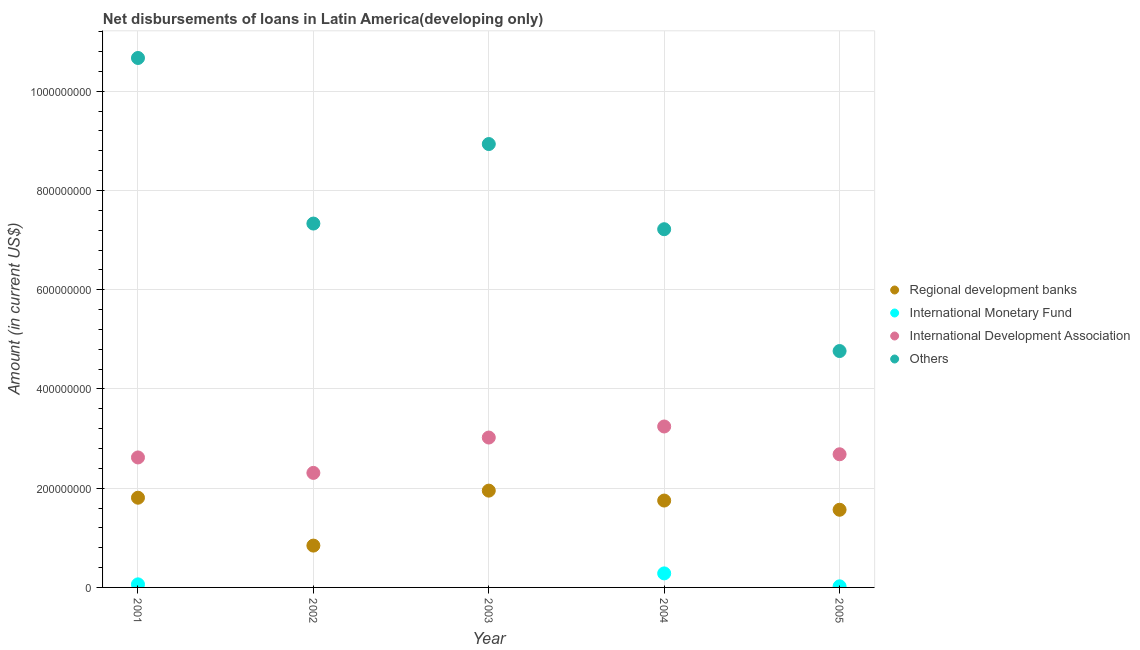How many different coloured dotlines are there?
Offer a very short reply. 4. Across all years, what is the maximum amount of loan disimbursed by international monetary fund?
Make the answer very short. 2.83e+07. Across all years, what is the minimum amount of loan disimbursed by other organisations?
Your response must be concise. 4.76e+08. In which year was the amount of loan disimbursed by international monetary fund maximum?
Your answer should be compact. 2004. What is the total amount of loan disimbursed by other organisations in the graph?
Offer a very short reply. 3.89e+09. What is the difference between the amount of loan disimbursed by regional development banks in 2003 and that in 2005?
Provide a succinct answer. 3.85e+07. What is the difference between the amount of loan disimbursed by international monetary fund in 2004 and the amount of loan disimbursed by regional development banks in 2005?
Your response must be concise. -1.28e+08. What is the average amount of loan disimbursed by international development association per year?
Your answer should be compact. 2.78e+08. In the year 2003, what is the difference between the amount of loan disimbursed by regional development banks and amount of loan disimbursed by other organisations?
Offer a terse response. -6.99e+08. In how many years, is the amount of loan disimbursed by international development association greater than 40000000 US$?
Give a very brief answer. 5. What is the ratio of the amount of loan disimbursed by other organisations in 2002 to that in 2005?
Your answer should be compact. 1.54. What is the difference between the highest and the second highest amount of loan disimbursed by international monetary fund?
Ensure brevity in your answer.  2.21e+07. What is the difference between the highest and the lowest amount of loan disimbursed by international development association?
Offer a terse response. 9.35e+07. In how many years, is the amount of loan disimbursed by international development association greater than the average amount of loan disimbursed by international development association taken over all years?
Your response must be concise. 2. Is it the case that in every year, the sum of the amount of loan disimbursed by international development association and amount of loan disimbursed by regional development banks is greater than the sum of amount of loan disimbursed by other organisations and amount of loan disimbursed by international monetary fund?
Provide a short and direct response. No. Does the amount of loan disimbursed by regional development banks monotonically increase over the years?
Give a very brief answer. No. Is the amount of loan disimbursed by international monetary fund strictly less than the amount of loan disimbursed by international development association over the years?
Your answer should be very brief. Yes. How many years are there in the graph?
Ensure brevity in your answer.  5. Are the values on the major ticks of Y-axis written in scientific E-notation?
Provide a short and direct response. No. Does the graph contain grids?
Keep it short and to the point. Yes. How many legend labels are there?
Your response must be concise. 4. How are the legend labels stacked?
Ensure brevity in your answer.  Vertical. What is the title of the graph?
Keep it short and to the point. Net disbursements of loans in Latin America(developing only). What is the label or title of the X-axis?
Provide a short and direct response. Year. What is the Amount (in current US$) in Regional development banks in 2001?
Provide a succinct answer. 1.81e+08. What is the Amount (in current US$) of International Monetary Fund in 2001?
Make the answer very short. 6.19e+06. What is the Amount (in current US$) in International Development Association in 2001?
Your answer should be compact. 2.62e+08. What is the Amount (in current US$) in Others in 2001?
Ensure brevity in your answer.  1.07e+09. What is the Amount (in current US$) in Regional development banks in 2002?
Provide a succinct answer. 8.43e+07. What is the Amount (in current US$) of International Development Association in 2002?
Give a very brief answer. 2.31e+08. What is the Amount (in current US$) of Others in 2002?
Offer a terse response. 7.33e+08. What is the Amount (in current US$) of Regional development banks in 2003?
Offer a terse response. 1.95e+08. What is the Amount (in current US$) of International Monetary Fund in 2003?
Your response must be concise. 0. What is the Amount (in current US$) in International Development Association in 2003?
Offer a terse response. 3.02e+08. What is the Amount (in current US$) in Others in 2003?
Your response must be concise. 8.94e+08. What is the Amount (in current US$) in Regional development banks in 2004?
Make the answer very short. 1.75e+08. What is the Amount (in current US$) of International Monetary Fund in 2004?
Provide a succinct answer. 2.83e+07. What is the Amount (in current US$) of International Development Association in 2004?
Ensure brevity in your answer.  3.24e+08. What is the Amount (in current US$) of Others in 2004?
Provide a succinct answer. 7.22e+08. What is the Amount (in current US$) in Regional development banks in 2005?
Your answer should be compact. 1.57e+08. What is the Amount (in current US$) of International Monetary Fund in 2005?
Give a very brief answer. 2.20e+06. What is the Amount (in current US$) in International Development Association in 2005?
Keep it short and to the point. 2.68e+08. What is the Amount (in current US$) of Others in 2005?
Provide a short and direct response. 4.76e+08. Across all years, what is the maximum Amount (in current US$) in Regional development banks?
Your answer should be very brief. 1.95e+08. Across all years, what is the maximum Amount (in current US$) of International Monetary Fund?
Your answer should be very brief. 2.83e+07. Across all years, what is the maximum Amount (in current US$) in International Development Association?
Offer a terse response. 3.24e+08. Across all years, what is the maximum Amount (in current US$) of Others?
Offer a very short reply. 1.07e+09. Across all years, what is the minimum Amount (in current US$) of Regional development banks?
Offer a terse response. 8.43e+07. Across all years, what is the minimum Amount (in current US$) of International Monetary Fund?
Your response must be concise. 0. Across all years, what is the minimum Amount (in current US$) in International Development Association?
Keep it short and to the point. 2.31e+08. Across all years, what is the minimum Amount (in current US$) of Others?
Provide a succinct answer. 4.76e+08. What is the total Amount (in current US$) in Regional development banks in the graph?
Offer a very short reply. 7.92e+08. What is the total Amount (in current US$) of International Monetary Fund in the graph?
Provide a short and direct response. 3.67e+07. What is the total Amount (in current US$) of International Development Association in the graph?
Provide a succinct answer. 1.39e+09. What is the total Amount (in current US$) of Others in the graph?
Provide a succinct answer. 3.89e+09. What is the difference between the Amount (in current US$) of Regional development banks in 2001 and that in 2002?
Ensure brevity in your answer.  9.65e+07. What is the difference between the Amount (in current US$) in International Development Association in 2001 and that in 2002?
Offer a very short reply. 3.11e+07. What is the difference between the Amount (in current US$) of Others in 2001 and that in 2002?
Provide a succinct answer. 3.34e+08. What is the difference between the Amount (in current US$) in Regional development banks in 2001 and that in 2003?
Your answer should be compact. -1.43e+07. What is the difference between the Amount (in current US$) of International Development Association in 2001 and that in 2003?
Give a very brief answer. -4.01e+07. What is the difference between the Amount (in current US$) of Others in 2001 and that in 2003?
Offer a very short reply. 1.73e+08. What is the difference between the Amount (in current US$) in Regional development banks in 2001 and that in 2004?
Offer a terse response. 5.72e+06. What is the difference between the Amount (in current US$) in International Monetary Fund in 2001 and that in 2004?
Provide a short and direct response. -2.21e+07. What is the difference between the Amount (in current US$) in International Development Association in 2001 and that in 2004?
Make the answer very short. -6.24e+07. What is the difference between the Amount (in current US$) in Others in 2001 and that in 2004?
Make the answer very short. 3.45e+08. What is the difference between the Amount (in current US$) in Regional development banks in 2001 and that in 2005?
Your response must be concise. 2.43e+07. What is the difference between the Amount (in current US$) of International Monetary Fund in 2001 and that in 2005?
Offer a terse response. 3.99e+06. What is the difference between the Amount (in current US$) of International Development Association in 2001 and that in 2005?
Offer a very short reply. -6.39e+06. What is the difference between the Amount (in current US$) of Others in 2001 and that in 2005?
Keep it short and to the point. 5.91e+08. What is the difference between the Amount (in current US$) in Regional development banks in 2002 and that in 2003?
Provide a succinct answer. -1.11e+08. What is the difference between the Amount (in current US$) in International Development Association in 2002 and that in 2003?
Provide a succinct answer. -7.13e+07. What is the difference between the Amount (in current US$) in Others in 2002 and that in 2003?
Your answer should be very brief. -1.60e+08. What is the difference between the Amount (in current US$) in Regional development banks in 2002 and that in 2004?
Keep it short and to the point. -9.08e+07. What is the difference between the Amount (in current US$) of International Development Association in 2002 and that in 2004?
Give a very brief answer. -9.35e+07. What is the difference between the Amount (in current US$) in Others in 2002 and that in 2004?
Provide a succinct answer. 1.14e+07. What is the difference between the Amount (in current US$) in Regional development banks in 2002 and that in 2005?
Make the answer very short. -7.22e+07. What is the difference between the Amount (in current US$) in International Development Association in 2002 and that in 2005?
Give a very brief answer. -3.75e+07. What is the difference between the Amount (in current US$) of Others in 2002 and that in 2005?
Provide a succinct answer. 2.57e+08. What is the difference between the Amount (in current US$) in Regional development banks in 2003 and that in 2004?
Offer a very short reply. 2.00e+07. What is the difference between the Amount (in current US$) of International Development Association in 2003 and that in 2004?
Ensure brevity in your answer.  -2.23e+07. What is the difference between the Amount (in current US$) of Others in 2003 and that in 2004?
Offer a very short reply. 1.72e+08. What is the difference between the Amount (in current US$) of Regional development banks in 2003 and that in 2005?
Your answer should be compact. 3.85e+07. What is the difference between the Amount (in current US$) in International Development Association in 2003 and that in 2005?
Your answer should be compact. 3.37e+07. What is the difference between the Amount (in current US$) of Others in 2003 and that in 2005?
Give a very brief answer. 4.17e+08. What is the difference between the Amount (in current US$) in Regional development banks in 2004 and that in 2005?
Ensure brevity in your answer.  1.86e+07. What is the difference between the Amount (in current US$) of International Monetary Fund in 2004 and that in 2005?
Make the answer very short. 2.61e+07. What is the difference between the Amount (in current US$) in International Development Association in 2004 and that in 2005?
Offer a terse response. 5.60e+07. What is the difference between the Amount (in current US$) in Others in 2004 and that in 2005?
Keep it short and to the point. 2.46e+08. What is the difference between the Amount (in current US$) in Regional development banks in 2001 and the Amount (in current US$) in International Development Association in 2002?
Your answer should be compact. -5.00e+07. What is the difference between the Amount (in current US$) of Regional development banks in 2001 and the Amount (in current US$) of Others in 2002?
Offer a very short reply. -5.53e+08. What is the difference between the Amount (in current US$) in International Monetary Fund in 2001 and the Amount (in current US$) in International Development Association in 2002?
Give a very brief answer. -2.25e+08. What is the difference between the Amount (in current US$) in International Monetary Fund in 2001 and the Amount (in current US$) in Others in 2002?
Ensure brevity in your answer.  -7.27e+08. What is the difference between the Amount (in current US$) in International Development Association in 2001 and the Amount (in current US$) in Others in 2002?
Your answer should be compact. -4.71e+08. What is the difference between the Amount (in current US$) in Regional development banks in 2001 and the Amount (in current US$) in International Development Association in 2003?
Your answer should be very brief. -1.21e+08. What is the difference between the Amount (in current US$) of Regional development banks in 2001 and the Amount (in current US$) of Others in 2003?
Provide a succinct answer. -7.13e+08. What is the difference between the Amount (in current US$) in International Monetary Fund in 2001 and the Amount (in current US$) in International Development Association in 2003?
Keep it short and to the point. -2.96e+08. What is the difference between the Amount (in current US$) of International Monetary Fund in 2001 and the Amount (in current US$) of Others in 2003?
Your answer should be very brief. -8.87e+08. What is the difference between the Amount (in current US$) of International Development Association in 2001 and the Amount (in current US$) of Others in 2003?
Your answer should be compact. -6.32e+08. What is the difference between the Amount (in current US$) of Regional development banks in 2001 and the Amount (in current US$) of International Monetary Fund in 2004?
Offer a terse response. 1.53e+08. What is the difference between the Amount (in current US$) in Regional development banks in 2001 and the Amount (in current US$) in International Development Association in 2004?
Keep it short and to the point. -1.44e+08. What is the difference between the Amount (in current US$) of Regional development banks in 2001 and the Amount (in current US$) of Others in 2004?
Give a very brief answer. -5.41e+08. What is the difference between the Amount (in current US$) in International Monetary Fund in 2001 and the Amount (in current US$) in International Development Association in 2004?
Provide a succinct answer. -3.18e+08. What is the difference between the Amount (in current US$) of International Monetary Fund in 2001 and the Amount (in current US$) of Others in 2004?
Your response must be concise. -7.16e+08. What is the difference between the Amount (in current US$) in International Development Association in 2001 and the Amount (in current US$) in Others in 2004?
Offer a very short reply. -4.60e+08. What is the difference between the Amount (in current US$) of Regional development banks in 2001 and the Amount (in current US$) of International Monetary Fund in 2005?
Give a very brief answer. 1.79e+08. What is the difference between the Amount (in current US$) in Regional development banks in 2001 and the Amount (in current US$) in International Development Association in 2005?
Offer a terse response. -8.76e+07. What is the difference between the Amount (in current US$) in Regional development banks in 2001 and the Amount (in current US$) in Others in 2005?
Keep it short and to the point. -2.96e+08. What is the difference between the Amount (in current US$) of International Monetary Fund in 2001 and the Amount (in current US$) of International Development Association in 2005?
Provide a succinct answer. -2.62e+08. What is the difference between the Amount (in current US$) in International Monetary Fund in 2001 and the Amount (in current US$) in Others in 2005?
Your response must be concise. -4.70e+08. What is the difference between the Amount (in current US$) in International Development Association in 2001 and the Amount (in current US$) in Others in 2005?
Your answer should be very brief. -2.14e+08. What is the difference between the Amount (in current US$) in Regional development banks in 2002 and the Amount (in current US$) in International Development Association in 2003?
Provide a succinct answer. -2.18e+08. What is the difference between the Amount (in current US$) of Regional development banks in 2002 and the Amount (in current US$) of Others in 2003?
Your response must be concise. -8.09e+08. What is the difference between the Amount (in current US$) of International Development Association in 2002 and the Amount (in current US$) of Others in 2003?
Keep it short and to the point. -6.63e+08. What is the difference between the Amount (in current US$) in Regional development banks in 2002 and the Amount (in current US$) in International Monetary Fund in 2004?
Offer a terse response. 5.60e+07. What is the difference between the Amount (in current US$) of Regional development banks in 2002 and the Amount (in current US$) of International Development Association in 2004?
Give a very brief answer. -2.40e+08. What is the difference between the Amount (in current US$) of Regional development banks in 2002 and the Amount (in current US$) of Others in 2004?
Provide a succinct answer. -6.38e+08. What is the difference between the Amount (in current US$) of International Development Association in 2002 and the Amount (in current US$) of Others in 2004?
Your answer should be very brief. -4.91e+08. What is the difference between the Amount (in current US$) in Regional development banks in 2002 and the Amount (in current US$) in International Monetary Fund in 2005?
Your answer should be compact. 8.21e+07. What is the difference between the Amount (in current US$) in Regional development banks in 2002 and the Amount (in current US$) in International Development Association in 2005?
Provide a succinct answer. -1.84e+08. What is the difference between the Amount (in current US$) in Regional development banks in 2002 and the Amount (in current US$) in Others in 2005?
Offer a very short reply. -3.92e+08. What is the difference between the Amount (in current US$) of International Development Association in 2002 and the Amount (in current US$) of Others in 2005?
Provide a succinct answer. -2.46e+08. What is the difference between the Amount (in current US$) in Regional development banks in 2003 and the Amount (in current US$) in International Monetary Fund in 2004?
Keep it short and to the point. 1.67e+08. What is the difference between the Amount (in current US$) in Regional development banks in 2003 and the Amount (in current US$) in International Development Association in 2004?
Keep it short and to the point. -1.29e+08. What is the difference between the Amount (in current US$) in Regional development banks in 2003 and the Amount (in current US$) in Others in 2004?
Give a very brief answer. -5.27e+08. What is the difference between the Amount (in current US$) of International Development Association in 2003 and the Amount (in current US$) of Others in 2004?
Your answer should be very brief. -4.20e+08. What is the difference between the Amount (in current US$) of Regional development banks in 2003 and the Amount (in current US$) of International Monetary Fund in 2005?
Your answer should be very brief. 1.93e+08. What is the difference between the Amount (in current US$) in Regional development banks in 2003 and the Amount (in current US$) in International Development Association in 2005?
Offer a terse response. -7.33e+07. What is the difference between the Amount (in current US$) in Regional development banks in 2003 and the Amount (in current US$) in Others in 2005?
Provide a short and direct response. -2.81e+08. What is the difference between the Amount (in current US$) of International Development Association in 2003 and the Amount (in current US$) of Others in 2005?
Provide a succinct answer. -1.74e+08. What is the difference between the Amount (in current US$) of Regional development banks in 2004 and the Amount (in current US$) of International Monetary Fund in 2005?
Keep it short and to the point. 1.73e+08. What is the difference between the Amount (in current US$) in Regional development banks in 2004 and the Amount (in current US$) in International Development Association in 2005?
Ensure brevity in your answer.  -9.33e+07. What is the difference between the Amount (in current US$) of Regional development banks in 2004 and the Amount (in current US$) of Others in 2005?
Your answer should be compact. -3.01e+08. What is the difference between the Amount (in current US$) of International Monetary Fund in 2004 and the Amount (in current US$) of International Development Association in 2005?
Give a very brief answer. -2.40e+08. What is the difference between the Amount (in current US$) of International Monetary Fund in 2004 and the Amount (in current US$) of Others in 2005?
Keep it short and to the point. -4.48e+08. What is the difference between the Amount (in current US$) of International Development Association in 2004 and the Amount (in current US$) of Others in 2005?
Provide a succinct answer. -1.52e+08. What is the average Amount (in current US$) of Regional development banks per year?
Ensure brevity in your answer.  1.58e+08. What is the average Amount (in current US$) of International Monetary Fund per year?
Provide a succinct answer. 7.33e+06. What is the average Amount (in current US$) of International Development Association per year?
Ensure brevity in your answer.  2.78e+08. What is the average Amount (in current US$) in Others per year?
Provide a succinct answer. 7.78e+08. In the year 2001, what is the difference between the Amount (in current US$) of Regional development banks and Amount (in current US$) of International Monetary Fund?
Offer a terse response. 1.75e+08. In the year 2001, what is the difference between the Amount (in current US$) in Regional development banks and Amount (in current US$) in International Development Association?
Give a very brief answer. -8.12e+07. In the year 2001, what is the difference between the Amount (in current US$) in Regional development banks and Amount (in current US$) in Others?
Make the answer very short. -8.86e+08. In the year 2001, what is the difference between the Amount (in current US$) of International Monetary Fund and Amount (in current US$) of International Development Association?
Make the answer very short. -2.56e+08. In the year 2001, what is the difference between the Amount (in current US$) of International Monetary Fund and Amount (in current US$) of Others?
Give a very brief answer. -1.06e+09. In the year 2001, what is the difference between the Amount (in current US$) of International Development Association and Amount (in current US$) of Others?
Give a very brief answer. -8.05e+08. In the year 2002, what is the difference between the Amount (in current US$) of Regional development banks and Amount (in current US$) of International Development Association?
Offer a terse response. -1.47e+08. In the year 2002, what is the difference between the Amount (in current US$) of Regional development banks and Amount (in current US$) of Others?
Offer a terse response. -6.49e+08. In the year 2002, what is the difference between the Amount (in current US$) of International Development Association and Amount (in current US$) of Others?
Keep it short and to the point. -5.03e+08. In the year 2003, what is the difference between the Amount (in current US$) of Regional development banks and Amount (in current US$) of International Development Association?
Your answer should be very brief. -1.07e+08. In the year 2003, what is the difference between the Amount (in current US$) in Regional development banks and Amount (in current US$) in Others?
Provide a short and direct response. -6.99e+08. In the year 2003, what is the difference between the Amount (in current US$) of International Development Association and Amount (in current US$) of Others?
Keep it short and to the point. -5.92e+08. In the year 2004, what is the difference between the Amount (in current US$) of Regional development banks and Amount (in current US$) of International Monetary Fund?
Give a very brief answer. 1.47e+08. In the year 2004, what is the difference between the Amount (in current US$) in Regional development banks and Amount (in current US$) in International Development Association?
Give a very brief answer. -1.49e+08. In the year 2004, what is the difference between the Amount (in current US$) of Regional development banks and Amount (in current US$) of Others?
Your answer should be compact. -5.47e+08. In the year 2004, what is the difference between the Amount (in current US$) in International Monetary Fund and Amount (in current US$) in International Development Association?
Offer a terse response. -2.96e+08. In the year 2004, what is the difference between the Amount (in current US$) of International Monetary Fund and Amount (in current US$) of Others?
Offer a very short reply. -6.94e+08. In the year 2004, what is the difference between the Amount (in current US$) in International Development Association and Amount (in current US$) in Others?
Your answer should be very brief. -3.98e+08. In the year 2005, what is the difference between the Amount (in current US$) of Regional development banks and Amount (in current US$) of International Monetary Fund?
Provide a succinct answer. 1.54e+08. In the year 2005, what is the difference between the Amount (in current US$) in Regional development banks and Amount (in current US$) in International Development Association?
Your response must be concise. -1.12e+08. In the year 2005, what is the difference between the Amount (in current US$) of Regional development banks and Amount (in current US$) of Others?
Offer a terse response. -3.20e+08. In the year 2005, what is the difference between the Amount (in current US$) of International Monetary Fund and Amount (in current US$) of International Development Association?
Give a very brief answer. -2.66e+08. In the year 2005, what is the difference between the Amount (in current US$) in International Monetary Fund and Amount (in current US$) in Others?
Offer a very short reply. -4.74e+08. In the year 2005, what is the difference between the Amount (in current US$) in International Development Association and Amount (in current US$) in Others?
Your answer should be compact. -2.08e+08. What is the ratio of the Amount (in current US$) in Regional development banks in 2001 to that in 2002?
Offer a terse response. 2.14. What is the ratio of the Amount (in current US$) in International Development Association in 2001 to that in 2002?
Give a very brief answer. 1.13. What is the ratio of the Amount (in current US$) of Others in 2001 to that in 2002?
Offer a terse response. 1.46. What is the ratio of the Amount (in current US$) in Regional development banks in 2001 to that in 2003?
Provide a short and direct response. 0.93. What is the ratio of the Amount (in current US$) in International Development Association in 2001 to that in 2003?
Keep it short and to the point. 0.87. What is the ratio of the Amount (in current US$) of Others in 2001 to that in 2003?
Keep it short and to the point. 1.19. What is the ratio of the Amount (in current US$) in Regional development banks in 2001 to that in 2004?
Your answer should be very brief. 1.03. What is the ratio of the Amount (in current US$) of International Monetary Fund in 2001 to that in 2004?
Your answer should be very brief. 0.22. What is the ratio of the Amount (in current US$) of International Development Association in 2001 to that in 2004?
Keep it short and to the point. 0.81. What is the ratio of the Amount (in current US$) in Others in 2001 to that in 2004?
Make the answer very short. 1.48. What is the ratio of the Amount (in current US$) of Regional development banks in 2001 to that in 2005?
Ensure brevity in your answer.  1.16. What is the ratio of the Amount (in current US$) of International Monetary Fund in 2001 to that in 2005?
Your response must be concise. 2.81. What is the ratio of the Amount (in current US$) in International Development Association in 2001 to that in 2005?
Ensure brevity in your answer.  0.98. What is the ratio of the Amount (in current US$) in Others in 2001 to that in 2005?
Your answer should be very brief. 2.24. What is the ratio of the Amount (in current US$) of Regional development banks in 2002 to that in 2003?
Make the answer very short. 0.43. What is the ratio of the Amount (in current US$) of International Development Association in 2002 to that in 2003?
Offer a very short reply. 0.76. What is the ratio of the Amount (in current US$) of Others in 2002 to that in 2003?
Keep it short and to the point. 0.82. What is the ratio of the Amount (in current US$) of Regional development banks in 2002 to that in 2004?
Give a very brief answer. 0.48. What is the ratio of the Amount (in current US$) in International Development Association in 2002 to that in 2004?
Keep it short and to the point. 0.71. What is the ratio of the Amount (in current US$) of Others in 2002 to that in 2004?
Ensure brevity in your answer.  1.02. What is the ratio of the Amount (in current US$) of Regional development banks in 2002 to that in 2005?
Provide a succinct answer. 0.54. What is the ratio of the Amount (in current US$) of International Development Association in 2002 to that in 2005?
Ensure brevity in your answer.  0.86. What is the ratio of the Amount (in current US$) in Others in 2002 to that in 2005?
Ensure brevity in your answer.  1.54. What is the ratio of the Amount (in current US$) of Regional development banks in 2003 to that in 2004?
Give a very brief answer. 1.11. What is the ratio of the Amount (in current US$) of International Development Association in 2003 to that in 2004?
Your answer should be compact. 0.93. What is the ratio of the Amount (in current US$) in Others in 2003 to that in 2004?
Give a very brief answer. 1.24. What is the ratio of the Amount (in current US$) in Regional development banks in 2003 to that in 2005?
Offer a very short reply. 1.25. What is the ratio of the Amount (in current US$) in International Development Association in 2003 to that in 2005?
Your answer should be very brief. 1.13. What is the ratio of the Amount (in current US$) in Others in 2003 to that in 2005?
Keep it short and to the point. 1.88. What is the ratio of the Amount (in current US$) of Regional development banks in 2004 to that in 2005?
Your response must be concise. 1.12. What is the ratio of the Amount (in current US$) in International Monetary Fund in 2004 to that in 2005?
Provide a short and direct response. 12.86. What is the ratio of the Amount (in current US$) of International Development Association in 2004 to that in 2005?
Give a very brief answer. 1.21. What is the ratio of the Amount (in current US$) in Others in 2004 to that in 2005?
Provide a succinct answer. 1.52. What is the difference between the highest and the second highest Amount (in current US$) of Regional development banks?
Your answer should be compact. 1.43e+07. What is the difference between the highest and the second highest Amount (in current US$) in International Monetary Fund?
Your answer should be compact. 2.21e+07. What is the difference between the highest and the second highest Amount (in current US$) in International Development Association?
Ensure brevity in your answer.  2.23e+07. What is the difference between the highest and the second highest Amount (in current US$) of Others?
Provide a short and direct response. 1.73e+08. What is the difference between the highest and the lowest Amount (in current US$) in Regional development banks?
Your answer should be very brief. 1.11e+08. What is the difference between the highest and the lowest Amount (in current US$) of International Monetary Fund?
Offer a terse response. 2.83e+07. What is the difference between the highest and the lowest Amount (in current US$) of International Development Association?
Your response must be concise. 9.35e+07. What is the difference between the highest and the lowest Amount (in current US$) in Others?
Your answer should be compact. 5.91e+08. 